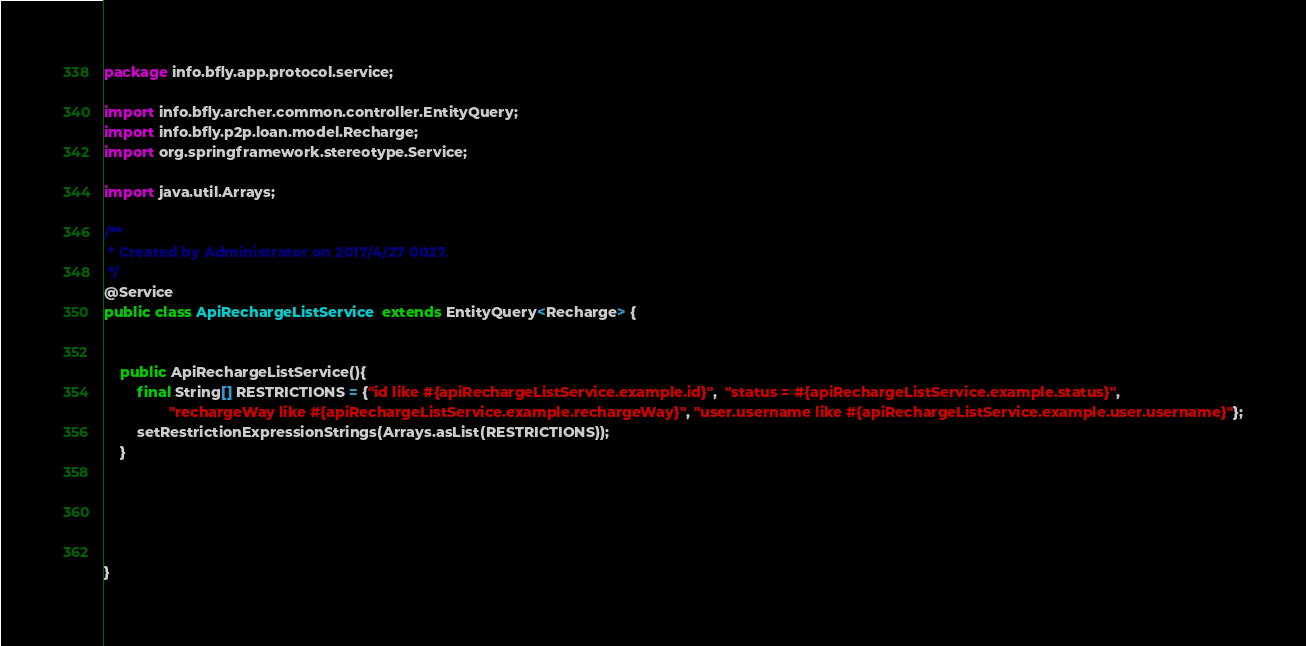Convert code to text. <code><loc_0><loc_0><loc_500><loc_500><_Java_>package info.bfly.app.protocol.service;

import info.bfly.archer.common.controller.EntityQuery;
import info.bfly.p2p.loan.model.Recharge;
import org.springframework.stereotype.Service;

import java.util.Arrays;

/**
 * Created by Administrator on 2017/4/27 0027.
 */
@Service
public class ApiRechargeListService  extends EntityQuery<Recharge> {


    public ApiRechargeListService(){
        final String[] RESTRICTIONS = {"id like #{apiRechargeListService.example.id}",  "status = #{apiRechargeListService.example.status}",
                "rechargeWay like #{apiRechargeListService.example.rechargeWay}", "user.username like #{apiRechargeListService.example.user.username}"};
        setRestrictionExpressionStrings(Arrays.asList(RESTRICTIONS));
    }





}
</code> 